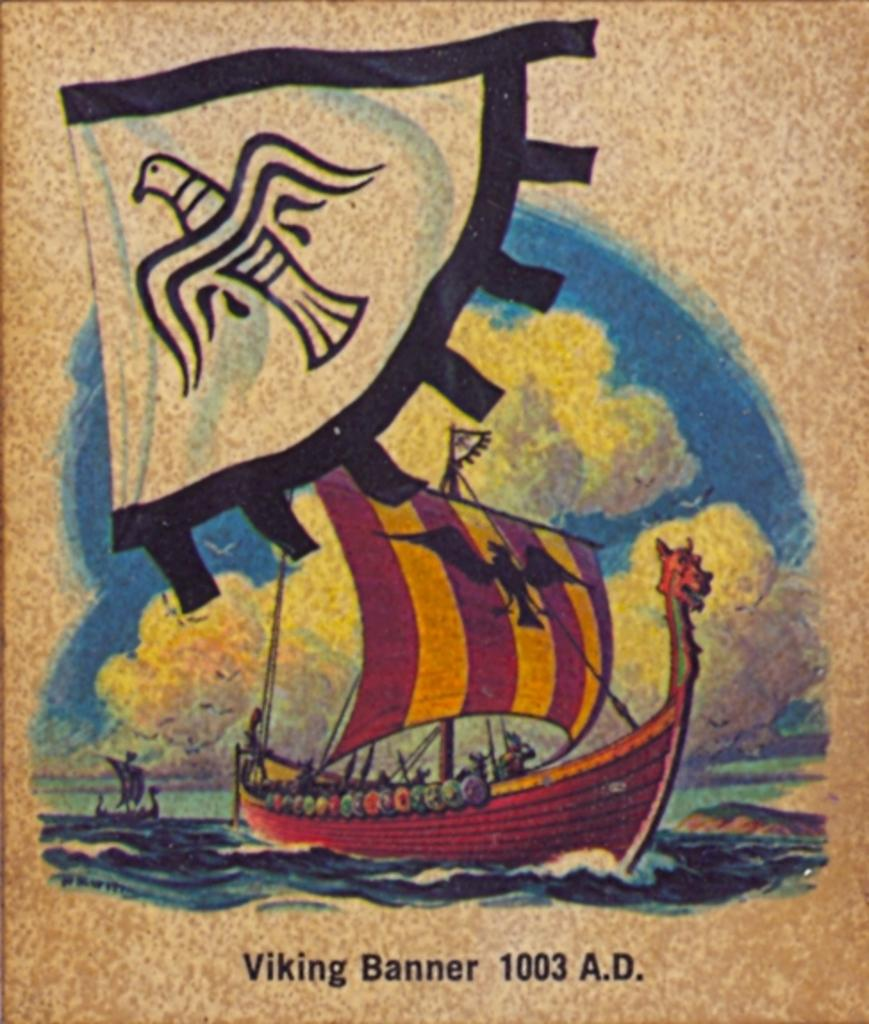<image>
Summarize the visual content of the image. A poster of Viking Banner 1003 A.D. that has a red boat on it. 